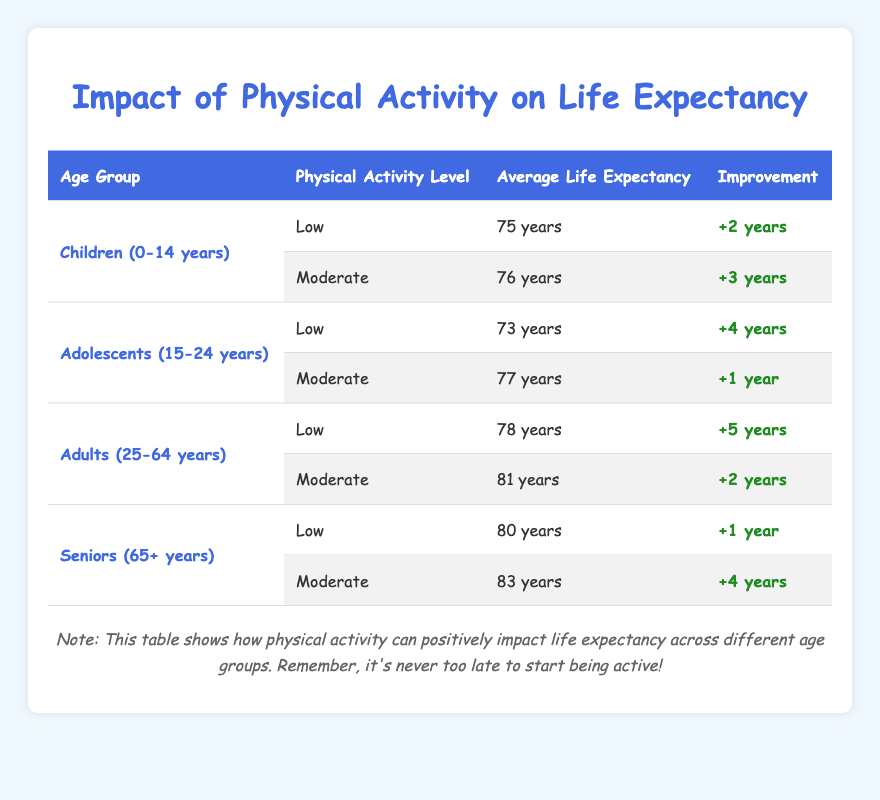What is the average life expectancy for children aged 0-14 years with low physical activity? The table shows that for children in the 0-14 years age group with low physical activity, the average life expectancy is listed as 75 years.
Answer: 75 years How much can moderate physical activity improve the life expectancy of seniors? According to the table, seniors (65+ years) can expect an improvement of +4 years in life expectancy with moderate physical activity.
Answer: +4 years Is the average life expectancy for adolescents with moderate physical activity higher than that for children with low physical activity? For adolescents aged 15-24 years with moderate physical activity, the average life expectancy is 77 years. For children aged 0-14 years with low physical activity, it is 75 years. Since 77 is greater than 75, the statement is true.
Answer: Yes Which age group shows the highest average life expectancy with low physical activity? The table indicates that for seniors aged 65+ years, the average life expectancy with low physical activity is 80 years, which is higher than the other age groups.
Answer: Seniors (65+ years) What is the combined life expectancy improvement for adults who engage in both low and moderate physical activity? For adults aged 25-64 years, with low physical activity, the improvement is +5 years, and with moderate activity, it is +2 years. Adding these two values gives +5 + 2 = +7 years in total.
Answer: +7 years Do children aged 0-14 years with moderate physical activity have a greater life expectancy than adolescents with low physical activity? Children (0-14 years) with moderate physical activity have an average life expectancy of 76 years, while adolescents (15-24 years) with low physical activity have 73 years. Since 76 is greater than 73, the answer is yes.
Answer: Yes What is the difference in average life expectancy between seniors with low and moderate physical activity? The average life expectancy for seniors (65+ years) with low physical activity is 80 years, and with moderate, it is 83 years. The difference can be calculated as 83 - 80 = 3 years.
Answer: 3 years What is the lowest average life expectancy recorded in the table? The lowest average life expectancy in the table is 73 years for adolescents aged 15-24 years with low physical activity.
Answer: 73 years 